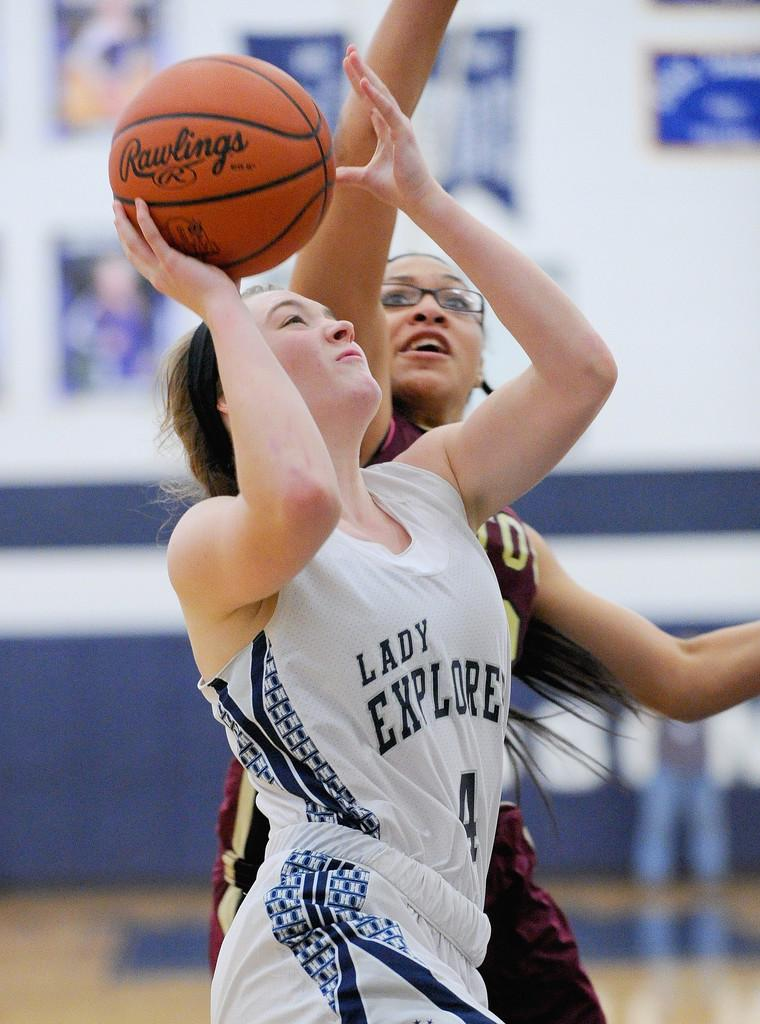Provide a one-sentence caption for the provided image. Two women play basketball with a Rawlings ball. 